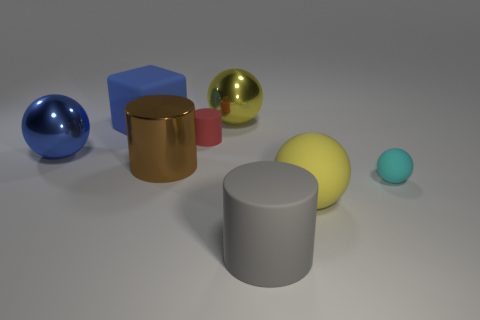Are there the same number of metallic objects to the right of the cyan rubber object and small red things?
Offer a terse response. No. What number of other things are made of the same material as the small cyan sphere?
Give a very brief answer. 4. Does the yellow ball in front of the small cyan matte thing have the same size as the matte cylinder that is behind the big brown metal cylinder?
Your response must be concise. No. How many objects are either large yellow rubber balls behind the large gray cylinder or tiny matte objects that are to the left of the big gray rubber thing?
Offer a very short reply. 2. Is there anything else that has the same shape as the cyan thing?
Give a very brief answer. Yes. Is the color of the thing that is right of the big matte ball the same as the tiny object that is to the left of the large gray rubber object?
Your answer should be very brief. No. How many metallic objects are big objects or cyan objects?
Provide a succinct answer. 3. Is there anything else that is the same size as the blue ball?
Give a very brief answer. Yes. The big yellow thing on the right side of the rubber cylinder in front of the big yellow matte sphere is what shape?
Provide a short and direct response. Sphere. Is the small object to the right of the gray thing made of the same material as the large block that is behind the blue metal thing?
Your answer should be compact. Yes. 